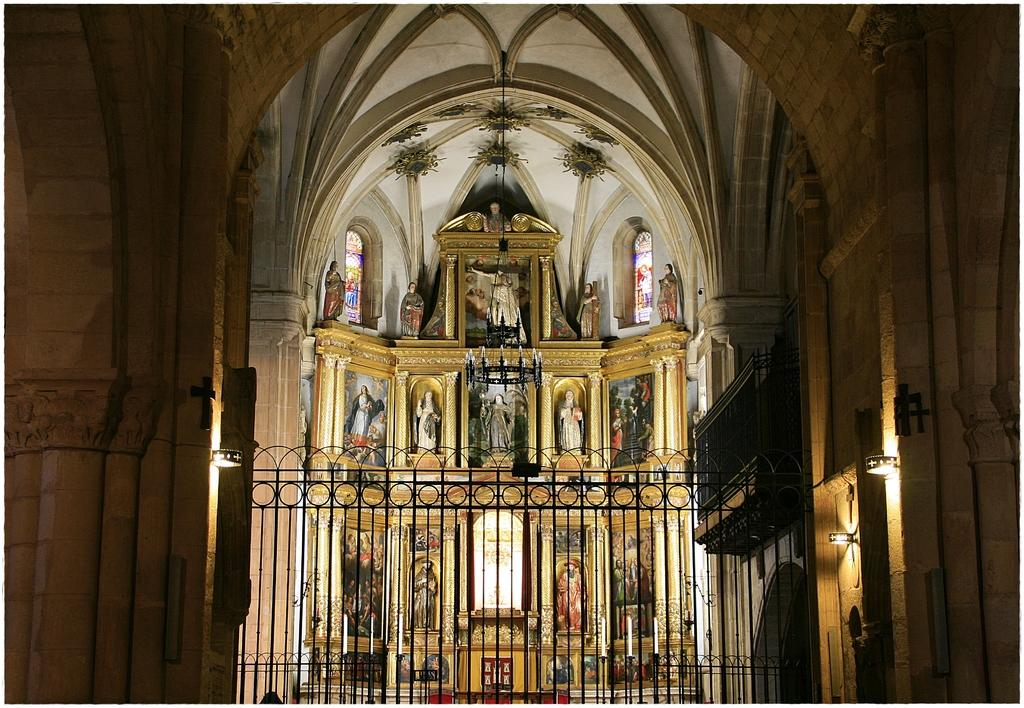What type of building is depicted in the image? The image is of the inside of a church. What is located at the front of the image? There is a gate at the front of the image. Where are the lights positioned in the image? There are lights on both the right and left sides of the image. What type of organization is hosting the party in the image? There is no party present in the image, as it depicts the inside of a church. What can be seen in the image related to dental care? There is no mention of teeth or dental care in the image, as it depicts the inside of a church. 